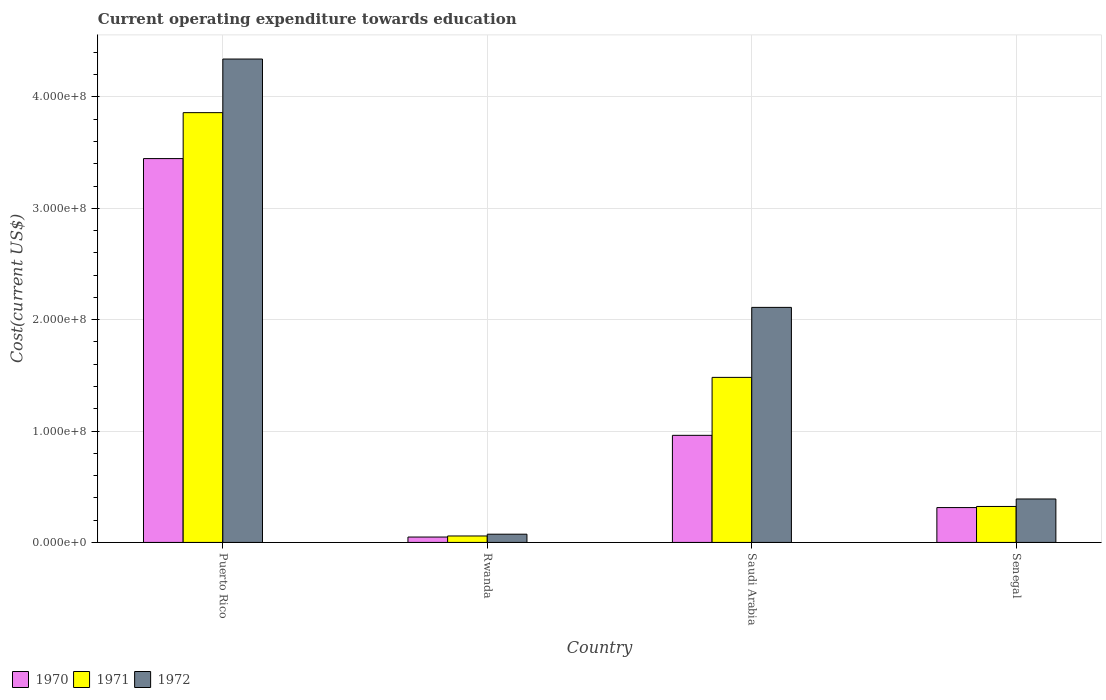Are the number of bars on each tick of the X-axis equal?
Provide a short and direct response. Yes. How many bars are there on the 3rd tick from the left?
Keep it short and to the point. 3. How many bars are there on the 3rd tick from the right?
Provide a short and direct response. 3. What is the label of the 1st group of bars from the left?
Make the answer very short. Puerto Rico. What is the expenditure towards education in 1970 in Rwanda?
Give a very brief answer. 4.84e+06. Across all countries, what is the maximum expenditure towards education in 1970?
Provide a short and direct response. 3.45e+08. Across all countries, what is the minimum expenditure towards education in 1970?
Your answer should be compact. 4.84e+06. In which country was the expenditure towards education in 1970 maximum?
Make the answer very short. Puerto Rico. In which country was the expenditure towards education in 1970 minimum?
Offer a terse response. Rwanda. What is the total expenditure towards education in 1970 in the graph?
Your response must be concise. 4.77e+08. What is the difference between the expenditure towards education in 1971 in Puerto Rico and that in Senegal?
Your response must be concise. 3.54e+08. What is the difference between the expenditure towards education in 1971 in Rwanda and the expenditure towards education in 1972 in Puerto Rico?
Your answer should be compact. -4.28e+08. What is the average expenditure towards education in 1972 per country?
Your answer should be very brief. 1.73e+08. What is the difference between the expenditure towards education of/in 1971 and expenditure towards education of/in 1972 in Saudi Arabia?
Provide a succinct answer. -6.28e+07. What is the ratio of the expenditure towards education in 1970 in Puerto Rico to that in Saudi Arabia?
Your response must be concise. 3.58. What is the difference between the highest and the second highest expenditure towards education in 1970?
Make the answer very short. -6.48e+07. What is the difference between the highest and the lowest expenditure towards education in 1972?
Provide a short and direct response. 4.27e+08. In how many countries, is the expenditure towards education in 1971 greater than the average expenditure towards education in 1971 taken over all countries?
Give a very brief answer. 2. Is the sum of the expenditure towards education in 1971 in Rwanda and Senegal greater than the maximum expenditure towards education in 1970 across all countries?
Offer a very short reply. No. What does the 1st bar from the left in Senegal represents?
Offer a terse response. 1970. How many bars are there?
Your answer should be very brief. 12. Are all the bars in the graph horizontal?
Provide a short and direct response. No. How many countries are there in the graph?
Make the answer very short. 4. What is the difference between two consecutive major ticks on the Y-axis?
Provide a succinct answer. 1.00e+08. Does the graph contain grids?
Provide a short and direct response. Yes. How many legend labels are there?
Provide a succinct answer. 3. What is the title of the graph?
Your answer should be very brief. Current operating expenditure towards education. Does "1997" appear as one of the legend labels in the graph?
Your answer should be very brief. No. What is the label or title of the Y-axis?
Your response must be concise. Cost(current US$). What is the Cost(current US$) in 1970 in Puerto Rico?
Make the answer very short. 3.45e+08. What is the Cost(current US$) of 1971 in Puerto Rico?
Ensure brevity in your answer.  3.86e+08. What is the Cost(current US$) of 1972 in Puerto Rico?
Your response must be concise. 4.34e+08. What is the Cost(current US$) of 1970 in Rwanda?
Your answer should be very brief. 4.84e+06. What is the Cost(current US$) in 1971 in Rwanda?
Your answer should be very brief. 5.80e+06. What is the Cost(current US$) of 1972 in Rwanda?
Offer a terse response. 7.40e+06. What is the Cost(current US$) in 1970 in Saudi Arabia?
Provide a short and direct response. 9.62e+07. What is the Cost(current US$) in 1971 in Saudi Arabia?
Ensure brevity in your answer.  1.48e+08. What is the Cost(current US$) of 1972 in Saudi Arabia?
Provide a succinct answer. 2.11e+08. What is the Cost(current US$) of 1970 in Senegal?
Provide a succinct answer. 3.13e+07. What is the Cost(current US$) of 1971 in Senegal?
Ensure brevity in your answer.  3.23e+07. What is the Cost(current US$) in 1972 in Senegal?
Give a very brief answer. 3.90e+07. Across all countries, what is the maximum Cost(current US$) of 1970?
Keep it short and to the point. 3.45e+08. Across all countries, what is the maximum Cost(current US$) of 1971?
Provide a succinct answer. 3.86e+08. Across all countries, what is the maximum Cost(current US$) in 1972?
Provide a succinct answer. 4.34e+08. Across all countries, what is the minimum Cost(current US$) of 1970?
Offer a terse response. 4.84e+06. Across all countries, what is the minimum Cost(current US$) of 1971?
Your response must be concise. 5.80e+06. Across all countries, what is the minimum Cost(current US$) in 1972?
Keep it short and to the point. 7.40e+06. What is the total Cost(current US$) of 1970 in the graph?
Ensure brevity in your answer.  4.77e+08. What is the total Cost(current US$) in 1971 in the graph?
Offer a terse response. 5.72e+08. What is the total Cost(current US$) of 1972 in the graph?
Offer a terse response. 6.91e+08. What is the difference between the Cost(current US$) of 1970 in Puerto Rico and that in Rwanda?
Your response must be concise. 3.40e+08. What is the difference between the Cost(current US$) of 1971 in Puerto Rico and that in Rwanda?
Your answer should be very brief. 3.80e+08. What is the difference between the Cost(current US$) in 1972 in Puerto Rico and that in Rwanda?
Your answer should be very brief. 4.27e+08. What is the difference between the Cost(current US$) of 1970 in Puerto Rico and that in Saudi Arabia?
Offer a terse response. 2.48e+08. What is the difference between the Cost(current US$) of 1971 in Puerto Rico and that in Saudi Arabia?
Provide a succinct answer. 2.38e+08. What is the difference between the Cost(current US$) of 1972 in Puerto Rico and that in Saudi Arabia?
Provide a succinct answer. 2.23e+08. What is the difference between the Cost(current US$) of 1970 in Puerto Rico and that in Senegal?
Make the answer very short. 3.13e+08. What is the difference between the Cost(current US$) in 1971 in Puerto Rico and that in Senegal?
Offer a terse response. 3.54e+08. What is the difference between the Cost(current US$) of 1972 in Puerto Rico and that in Senegal?
Offer a very short reply. 3.95e+08. What is the difference between the Cost(current US$) in 1970 in Rwanda and that in Saudi Arabia?
Your response must be concise. -9.13e+07. What is the difference between the Cost(current US$) of 1971 in Rwanda and that in Saudi Arabia?
Provide a short and direct response. -1.42e+08. What is the difference between the Cost(current US$) of 1972 in Rwanda and that in Saudi Arabia?
Keep it short and to the point. -2.04e+08. What is the difference between the Cost(current US$) in 1970 in Rwanda and that in Senegal?
Give a very brief answer. -2.65e+07. What is the difference between the Cost(current US$) of 1971 in Rwanda and that in Senegal?
Give a very brief answer. -2.65e+07. What is the difference between the Cost(current US$) in 1972 in Rwanda and that in Senegal?
Your response must be concise. -3.16e+07. What is the difference between the Cost(current US$) in 1970 in Saudi Arabia and that in Senegal?
Offer a very short reply. 6.48e+07. What is the difference between the Cost(current US$) of 1971 in Saudi Arabia and that in Senegal?
Make the answer very short. 1.16e+08. What is the difference between the Cost(current US$) of 1972 in Saudi Arabia and that in Senegal?
Make the answer very short. 1.72e+08. What is the difference between the Cost(current US$) of 1970 in Puerto Rico and the Cost(current US$) of 1971 in Rwanda?
Ensure brevity in your answer.  3.39e+08. What is the difference between the Cost(current US$) of 1970 in Puerto Rico and the Cost(current US$) of 1972 in Rwanda?
Your response must be concise. 3.37e+08. What is the difference between the Cost(current US$) in 1971 in Puerto Rico and the Cost(current US$) in 1972 in Rwanda?
Provide a short and direct response. 3.78e+08. What is the difference between the Cost(current US$) of 1970 in Puerto Rico and the Cost(current US$) of 1971 in Saudi Arabia?
Keep it short and to the point. 1.96e+08. What is the difference between the Cost(current US$) in 1970 in Puerto Rico and the Cost(current US$) in 1972 in Saudi Arabia?
Keep it short and to the point. 1.34e+08. What is the difference between the Cost(current US$) in 1971 in Puerto Rico and the Cost(current US$) in 1972 in Saudi Arabia?
Provide a succinct answer. 1.75e+08. What is the difference between the Cost(current US$) in 1970 in Puerto Rico and the Cost(current US$) in 1971 in Senegal?
Provide a short and direct response. 3.12e+08. What is the difference between the Cost(current US$) in 1970 in Puerto Rico and the Cost(current US$) in 1972 in Senegal?
Offer a very short reply. 3.06e+08. What is the difference between the Cost(current US$) of 1971 in Puerto Rico and the Cost(current US$) of 1972 in Senegal?
Your answer should be very brief. 3.47e+08. What is the difference between the Cost(current US$) in 1970 in Rwanda and the Cost(current US$) in 1971 in Saudi Arabia?
Keep it short and to the point. -1.43e+08. What is the difference between the Cost(current US$) in 1970 in Rwanda and the Cost(current US$) in 1972 in Saudi Arabia?
Keep it short and to the point. -2.06e+08. What is the difference between the Cost(current US$) of 1971 in Rwanda and the Cost(current US$) of 1972 in Saudi Arabia?
Ensure brevity in your answer.  -2.05e+08. What is the difference between the Cost(current US$) in 1970 in Rwanda and the Cost(current US$) in 1971 in Senegal?
Give a very brief answer. -2.75e+07. What is the difference between the Cost(current US$) in 1970 in Rwanda and the Cost(current US$) in 1972 in Senegal?
Make the answer very short. -3.42e+07. What is the difference between the Cost(current US$) in 1971 in Rwanda and the Cost(current US$) in 1972 in Senegal?
Offer a terse response. -3.32e+07. What is the difference between the Cost(current US$) in 1970 in Saudi Arabia and the Cost(current US$) in 1971 in Senegal?
Offer a terse response. 6.39e+07. What is the difference between the Cost(current US$) of 1970 in Saudi Arabia and the Cost(current US$) of 1972 in Senegal?
Provide a succinct answer. 5.71e+07. What is the difference between the Cost(current US$) of 1971 in Saudi Arabia and the Cost(current US$) of 1972 in Senegal?
Provide a short and direct response. 1.09e+08. What is the average Cost(current US$) in 1970 per country?
Your answer should be very brief. 1.19e+08. What is the average Cost(current US$) of 1971 per country?
Provide a succinct answer. 1.43e+08. What is the average Cost(current US$) of 1972 per country?
Ensure brevity in your answer.  1.73e+08. What is the difference between the Cost(current US$) of 1970 and Cost(current US$) of 1971 in Puerto Rico?
Your answer should be compact. -4.12e+07. What is the difference between the Cost(current US$) of 1970 and Cost(current US$) of 1972 in Puerto Rico?
Your answer should be compact. -8.94e+07. What is the difference between the Cost(current US$) of 1971 and Cost(current US$) of 1972 in Puerto Rico?
Your answer should be compact. -4.81e+07. What is the difference between the Cost(current US$) in 1970 and Cost(current US$) in 1971 in Rwanda?
Make the answer very short. -9.57e+05. What is the difference between the Cost(current US$) in 1970 and Cost(current US$) in 1972 in Rwanda?
Ensure brevity in your answer.  -2.56e+06. What is the difference between the Cost(current US$) of 1971 and Cost(current US$) of 1972 in Rwanda?
Provide a short and direct response. -1.60e+06. What is the difference between the Cost(current US$) of 1970 and Cost(current US$) of 1971 in Saudi Arabia?
Ensure brevity in your answer.  -5.20e+07. What is the difference between the Cost(current US$) of 1970 and Cost(current US$) of 1972 in Saudi Arabia?
Your answer should be compact. -1.15e+08. What is the difference between the Cost(current US$) of 1971 and Cost(current US$) of 1972 in Saudi Arabia?
Make the answer very short. -6.28e+07. What is the difference between the Cost(current US$) in 1970 and Cost(current US$) in 1971 in Senegal?
Offer a terse response. -9.86e+05. What is the difference between the Cost(current US$) in 1970 and Cost(current US$) in 1972 in Senegal?
Give a very brief answer. -7.71e+06. What is the difference between the Cost(current US$) of 1971 and Cost(current US$) of 1972 in Senegal?
Keep it short and to the point. -6.72e+06. What is the ratio of the Cost(current US$) in 1970 in Puerto Rico to that in Rwanda?
Ensure brevity in your answer.  71.2. What is the ratio of the Cost(current US$) in 1971 in Puerto Rico to that in Rwanda?
Provide a succinct answer. 66.57. What is the ratio of the Cost(current US$) in 1972 in Puerto Rico to that in Rwanda?
Offer a terse response. 58.67. What is the ratio of the Cost(current US$) in 1970 in Puerto Rico to that in Saudi Arabia?
Your answer should be very brief. 3.58. What is the ratio of the Cost(current US$) in 1971 in Puerto Rico to that in Saudi Arabia?
Provide a short and direct response. 2.6. What is the ratio of the Cost(current US$) in 1972 in Puerto Rico to that in Saudi Arabia?
Make the answer very short. 2.06. What is the ratio of the Cost(current US$) in 1970 in Puerto Rico to that in Senegal?
Ensure brevity in your answer.  11.01. What is the ratio of the Cost(current US$) of 1971 in Puerto Rico to that in Senegal?
Ensure brevity in your answer.  11.95. What is the ratio of the Cost(current US$) of 1972 in Puerto Rico to that in Senegal?
Give a very brief answer. 11.12. What is the ratio of the Cost(current US$) in 1970 in Rwanda to that in Saudi Arabia?
Make the answer very short. 0.05. What is the ratio of the Cost(current US$) of 1971 in Rwanda to that in Saudi Arabia?
Provide a short and direct response. 0.04. What is the ratio of the Cost(current US$) of 1972 in Rwanda to that in Saudi Arabia?
Your answer should be compact. 0.04. What is the ratio of the Cost(current US$) of 1970 in Rwanda to that in Senegal?
Provide a short and direct response. 0.15. What is the ratio of the Cost(current US$) in 1971 in Rwanda to that in Senegal?
Offer a very short reply. 0.18. What is the ratio of the Cost(current US$) of 1972 in Rwanda to that in Senegal?
Your response must be concise. 0.19. What is the ratio of the Cost(current US$) of 1970 in Saudi Arabia to that in Senegal?
Provide a short and direct response. 3.07. What is the ratio of the Cost(current US$) in 1971 in Saudi Arabia to that in Senegal?
Your answer should be very brief. 4.59. What is the ratio of the Cost(current US$) in 1972 in Saudi Arabia to that in Senegal?
Keep it short and to the point. 5.41. What is the difference between the highest and the second highest Cost(current US$) in 1970?
Your answer should be very brief. 2.48e+08. What is the difference between the highest and the second highest Cost(current US$) in 1971?
Your answer should be very brief. 2.38e+08. What is the difference between the highest and the second highest Cost(current US$) in 1972?
Your answer should be compact. 2.23e+08. What is the difference between the highest and the lowest Cost(current US$) in 1970?
Offer a very short reply. 3.40e+08. What is the difference between the highest and the lowest Cost(current US$) in 1971?
Your answer should be compact. 3.80e+08. What is the difference between the highest and the lowest Cost(current US$) of 1972?
Your answer should be very brief. 4.27e+08. 